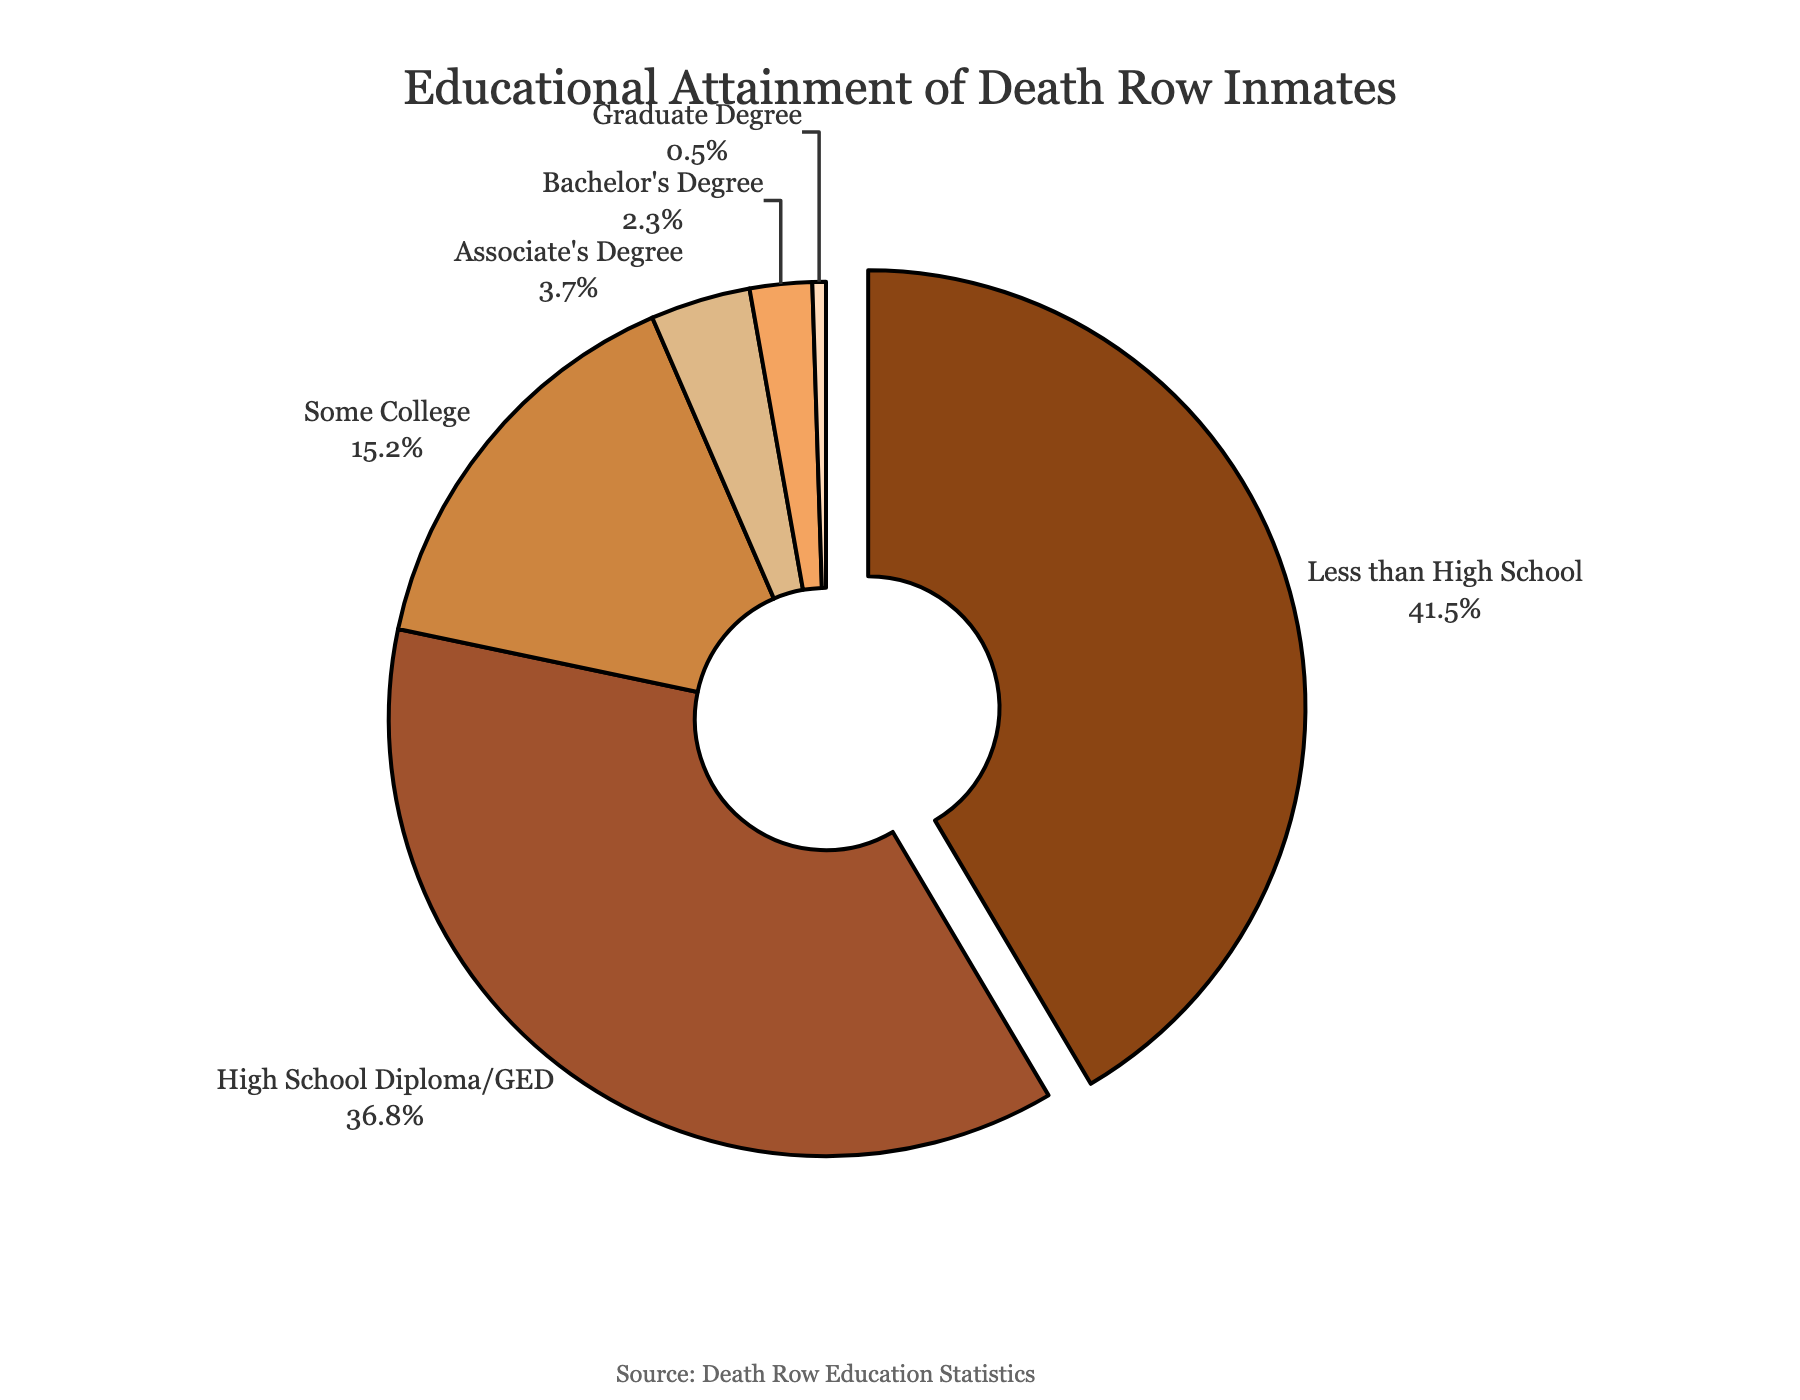What percentage of death row inmates have at least a high school diploma or GED? First, identify the percentage of those with a high school diploma/GED, which is 36.8%. Then sum this with the percentages of inmates with higher education levels: Some College (15.2%), Associate's Degree (3.7%), Bachelor's Degree (2.3%), and Graduate Degree (0.5%). The total is 36.8% + 15.2% + 3.7% + 2.3% + 0.5% = 58.5%
Answer: 58.5% Which educational level has the lowest representation among death row inmates? By observing the percentages given in the figure, the Graduate Degree has the lowest representation with only 0.5%.
Answer: Graduate Degree How much more common is not finishing high school compared to obtaining a bachelor's degree among death row inmates? The percentage of inmates who did not finish high school is 41.5%, and those who have a bachelor's degree is 2.3%. The difference is 41.5% - 2.3% = 39.2%.
Answer: 39.2% What is the total percentage of death row inmates who have some form of college education (at least some college)? Sum the percentages of inmates with Some College (15.2%), Associate's Degree (3.7%), Bachelor's Degree (2.3%), and Graduate Degree (0.5%). The total is 15.2% + 3.7% + 2.3% + 0.5% = 21.7%.
Answer: 21.7% Compare the representation of inmates with an associate's degree to those with a high school diploma or GED. Which group is larger, and by what percentage? Inmates with an associate's degree account for 3.7%, while those with a high school diploma or GED account for 36.8%. The high school diploma/GED group is larger by 36.8% - 3.7% = 33.1%.
Answer: The high school diploma/GED group is larger by 33.1% If you combine inmates with less than a high school education and those with only a high school diploma or GED, what percentage of the total does this combined group represent? Sum the percentages for Less than High School (41.5%) and High School Diploma/GED (36.8%). The total is 41.5% + 36.8% = 78.3%.
Answer: 78.3% What is the most common educational attainment level among death row inmates? By comparing the given percentages, Less than High School has the highest representation with 41.5%.
Answer: Less than High School How does the percentage of inmates with some college compare to the percentage of inmates with less than high school education? The percentage of inmates with Some College is 15.2%, while those with less than high school education is 41.5%. Less than high school education is more common by 41.5% - 15.2% = 26.3%.
Answer: Less than high school education is more common by 26.3% What percentage of death row inmates have either an associate's degree or a bachelor's degree? Sum the percentages for Associate's Degree (3.7%) and Bachelor's Degree (2.3%). The total is 3.7% + 2.3% = 6.0%.
Answer: 6.0% Compare the total percentage of inmates with higher education (Associate's Degree and above) to those with only a high school diploma or GED. The total percentage for higher education (Associate's Degree and above) is the sum of Associate's Degree (3.7%), Bachelor's Degree (2.3%), and Graduate Degree (0.5%) which equals 3.7% + 2.3% + 0.5% = 6.5%. The percentage for the high school diploma/GED group alone is 36.8%. High school diploma/GED is more common by 36.8% - 6.5% = 30.3%.
Answer: High school diploma/GED is more common by 30.3% 